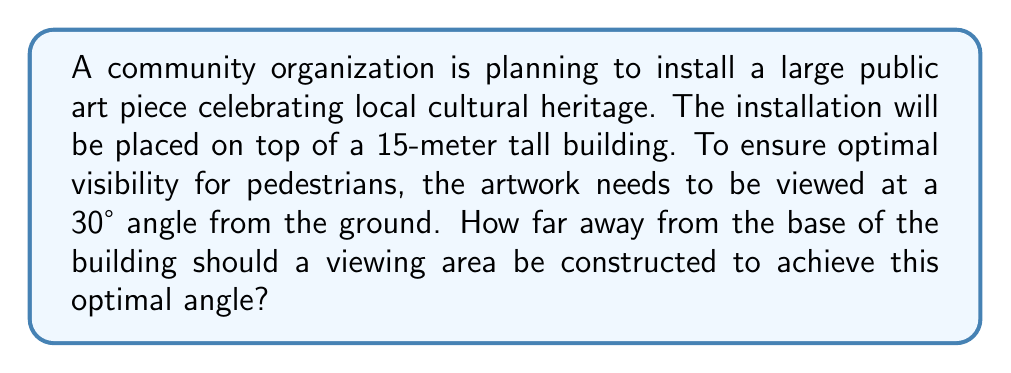Solve this math problem. Let's approach this step-by-step using trigonometry:

1) We can visualize this scenario as a right triangle, where:
   - The height of the building is the opposite side (15 meters)
   - The distance from the building to the viewing area is the adjacent side (what we're solving for)
   - The angle of elevation from the viewing area to the top of the artwork is 30°

2) In this right triangle, we know:
   - The opposite side (O) = 15 meters
   - The angle (θ) = 30°
   - We need to find the adjacent side (A)

3) The trigonometric ratio that relates the adjacent side to the opposite side and the angle is the tangent:

   $$\tan θ = \frac{O}{A}$$

4) We can rearrange this to solve for A:

   $$A = \frac{O}{\tan θ}$$

5) Substituting our known values:

   $$A = \frac{15}{\tan 30°}$$

6) We know that $\tan 30° = \frac{1}{\sqrt{3}}$, so:

   $$A = 15 \cdot \sqrt{3}$$

7) Simplifying:

   $$A ≈ 25.98 \text{ meters}$$

[asy]
import geometry;

size(200);
pair A = (0,0), B = (260,0), C = (0,150);
draw(A--B--C--A);
draw(rightanglemark(A,B,C,20));

label("15m", C--A, W);
label("25.98m", A--B, S);
label("30°", B, SE);

dot("Viewing Area", B, SE);
dot("Artwork", C, NW);
[/asy]
Answer: $25.98 \text{ meters}$ 